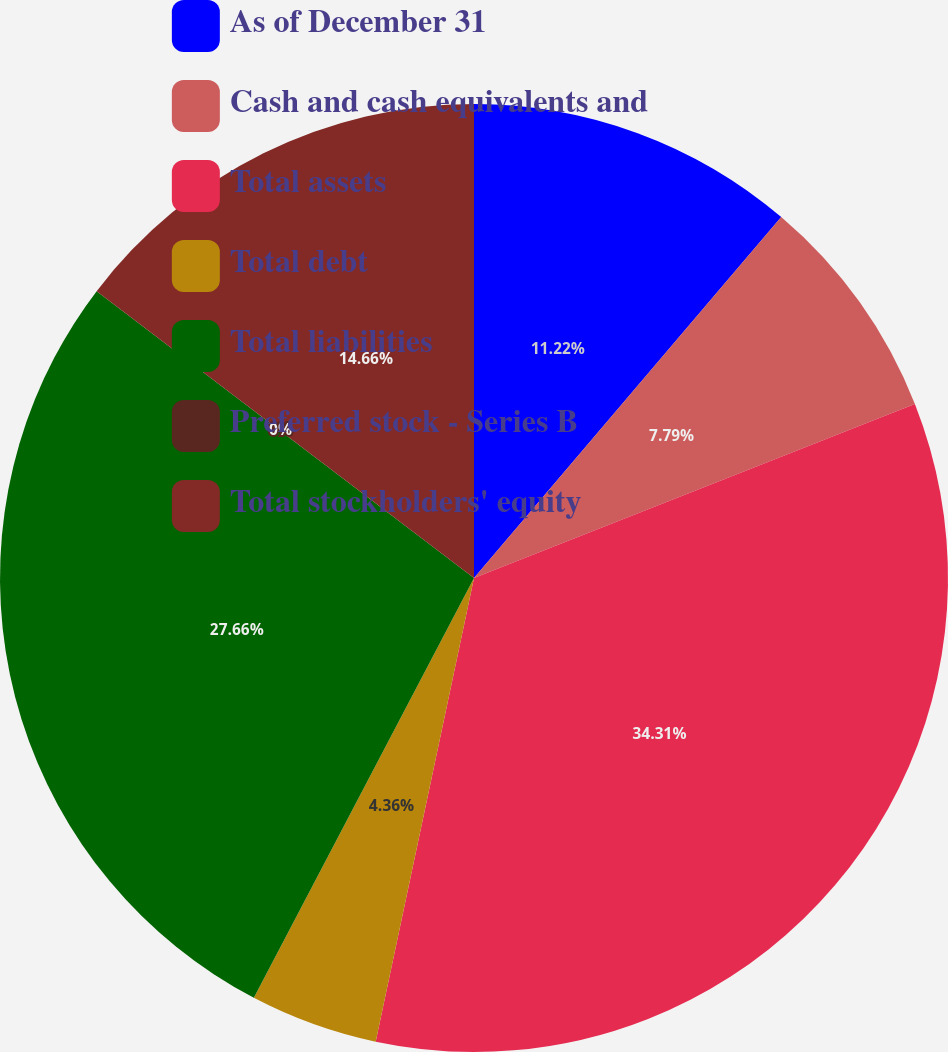Convert chart. <chart><loc_0><loc_0><loc_500><loc_500><pie_chart><fcel>As of December 31<fcel>Cash and cash equivalents and<fcel>Total assets<fcel>Total debt<fcel>Total liabilities<fcel>Preferred stock - Series B<fcel>Total stockholders' equity<nl><fcel>11.22%<fcel>7.79%<fcel>34.3%<fcel>4.36%<fcel>27.65%<fcel>0.0%<fcel>14.65%<nl></chart> 